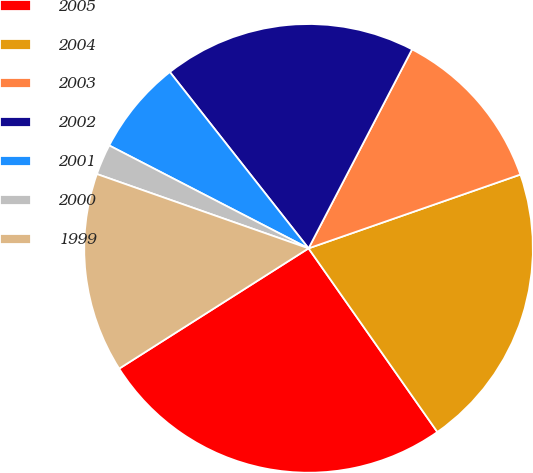<chart> <loc_0><loc_0><loc_500><loc_500><pie_chart><fcel>2005<fcel>2004<fcel>2003<fcel>2002<fcel>2001<fcel>2000<fcel>1999<nl><fcel>25.73%<fcel>20.6%<fcel>12.03%<fcel>18.24%<fcel>6.81%<fcel>2.21%<fcel>14.38%<nl></chart> 